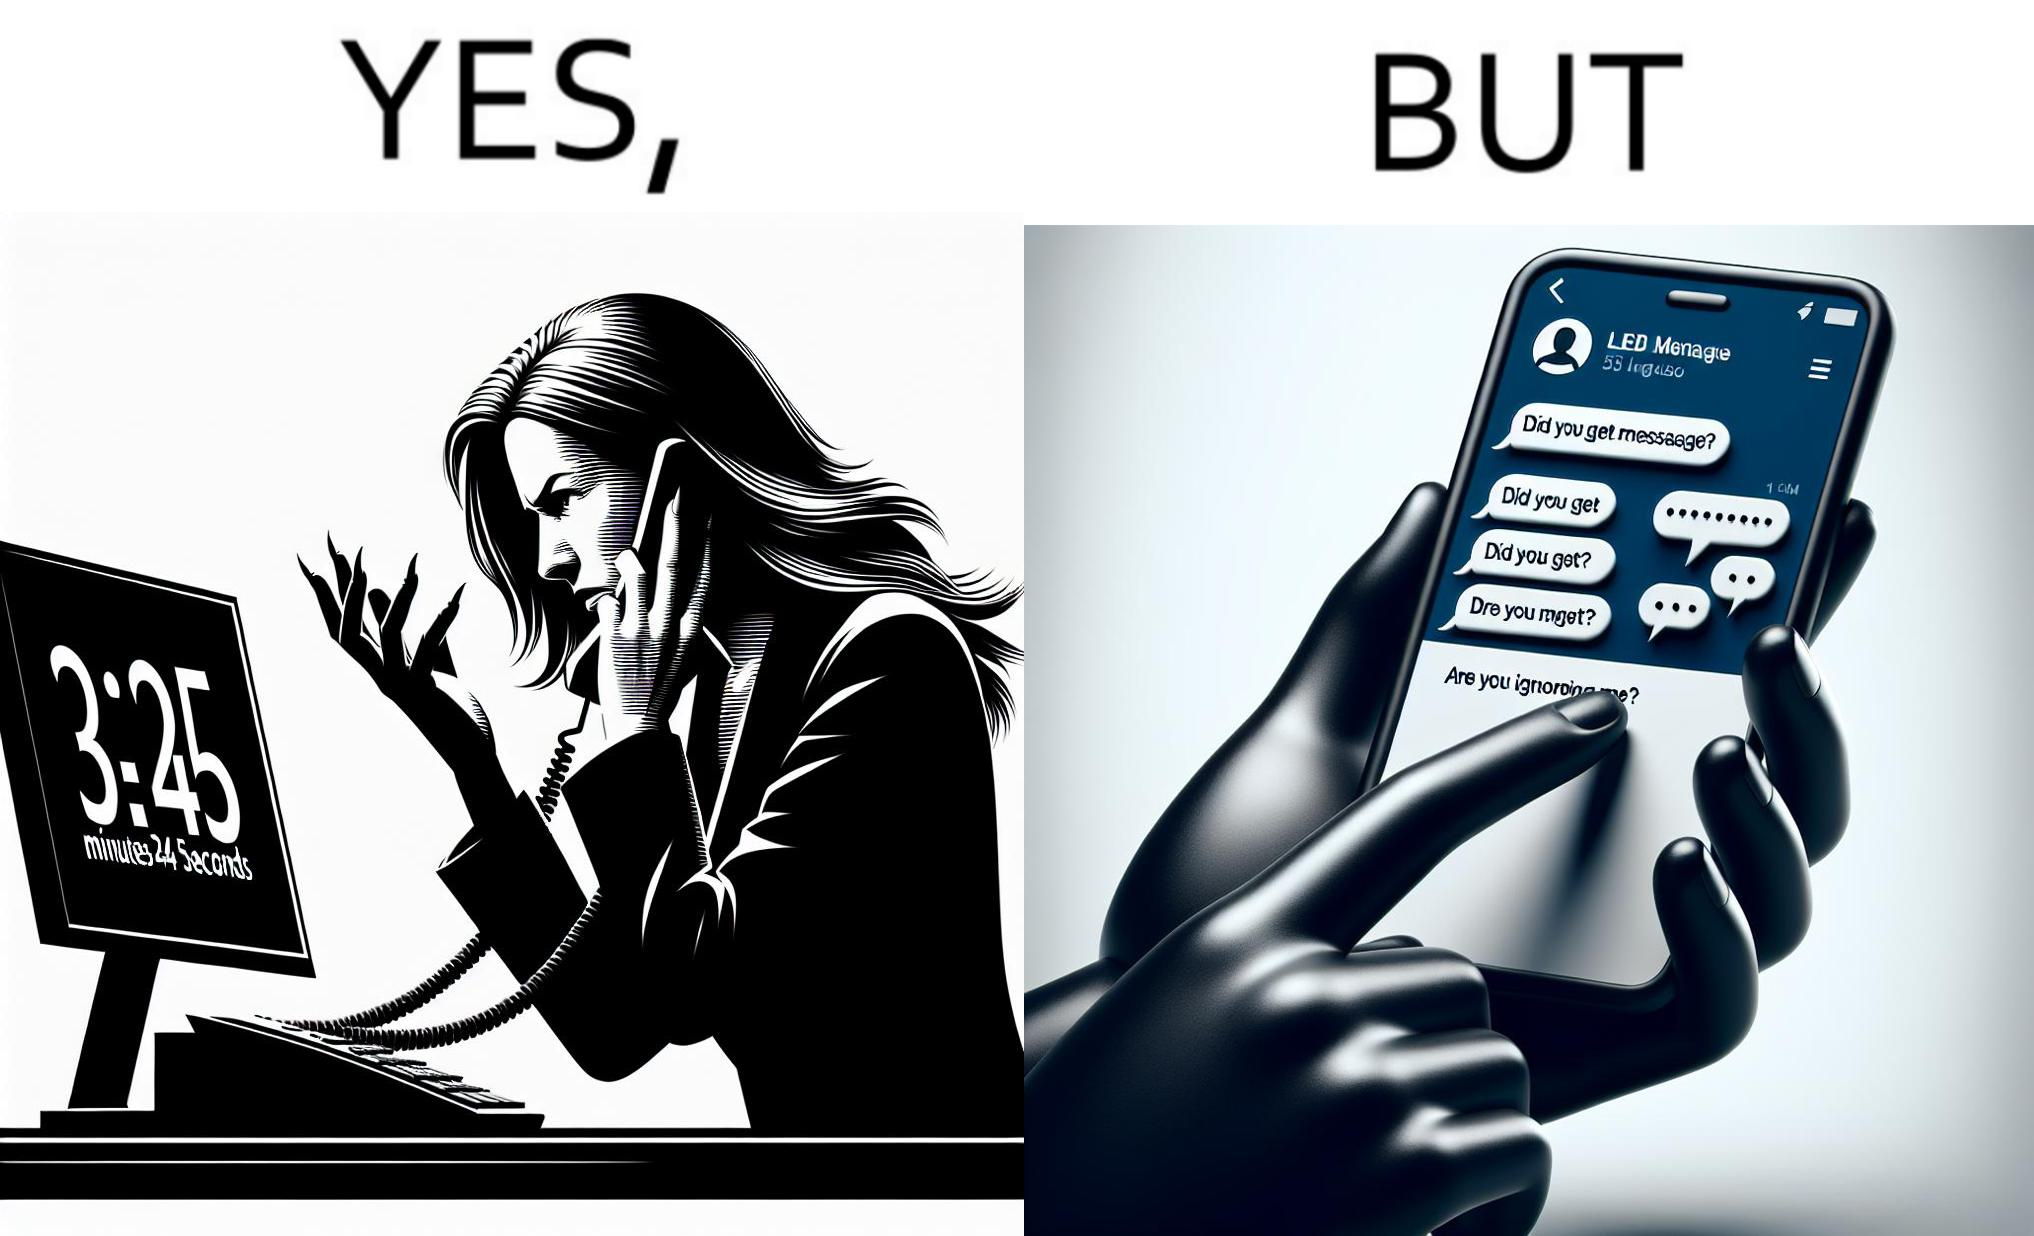Is this a satirical image? Yes, this image is satirical. 